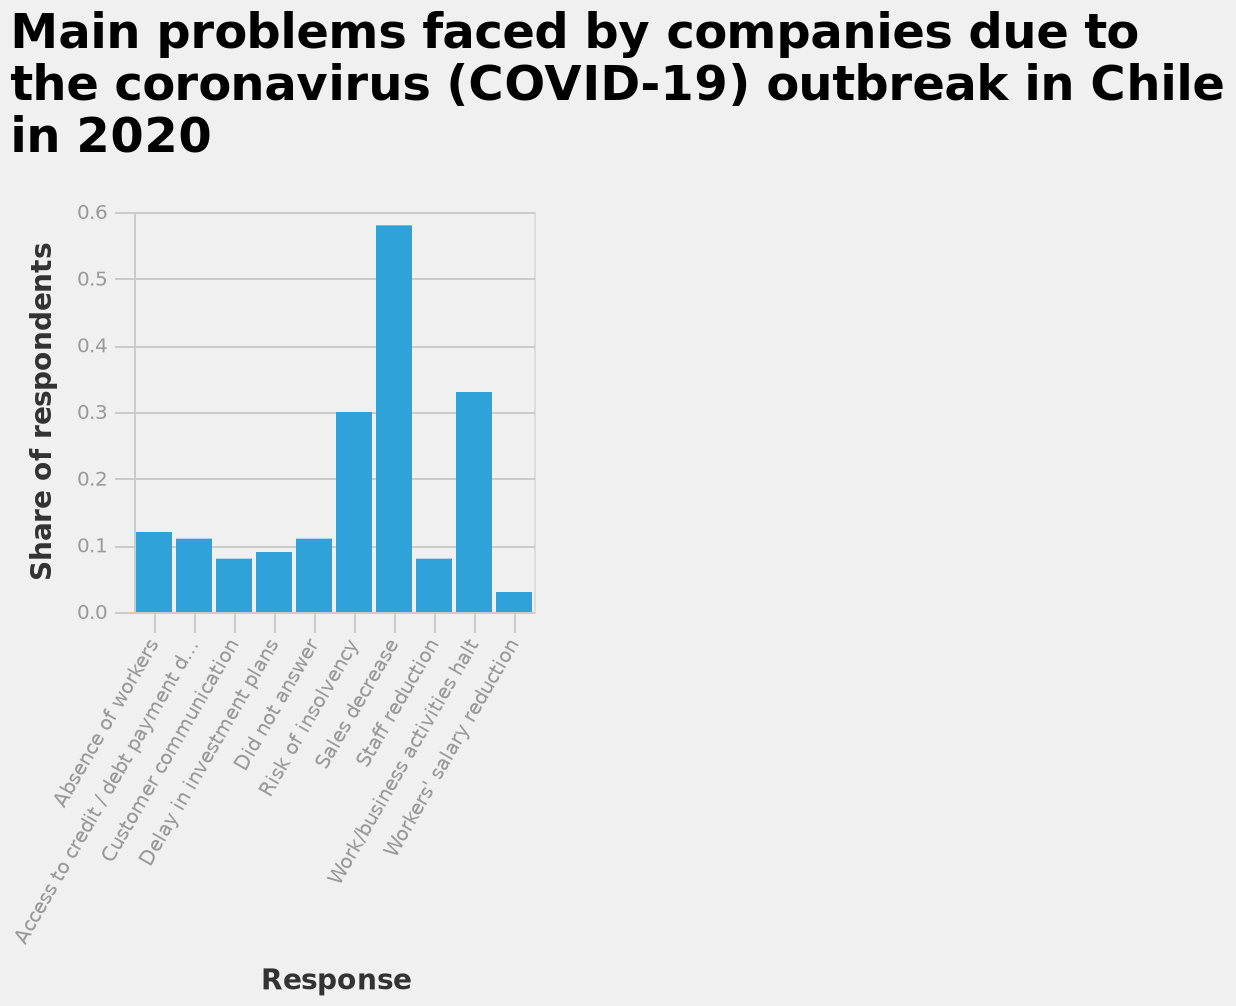<image>
How did worker's salaries in Chile fare during the Covid pandemic?  Worker's Salary Reduction was one of the least affected areas overall during the Covid pandemic in Chile. What does the x-axis measure in the bar diagram?  The x-axis measures the response with a categorical scale ranging from Absence of workers to Workers' salary reduction. What was the impact of the Covid pandemic on sales in Chile?  The Covid pandemic caused a Sales Decrease of more than 0.55 in Chile. 